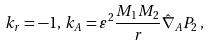<formula> <loc_0><loc_0><loc_500><loc_500>k _ { r } = - 1 , \, k _ { A } = \varepsilon ^ { 2 } \frac { M _ { 1 } M _ { 2 } } { r } \hat { \nabla } _ { A } P _ { 2 } \, ,</formula> 